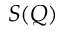Convert formula to latex. <formula><loc_0><loc_0><loc_500><loc_500>S ( Q )</formula> 